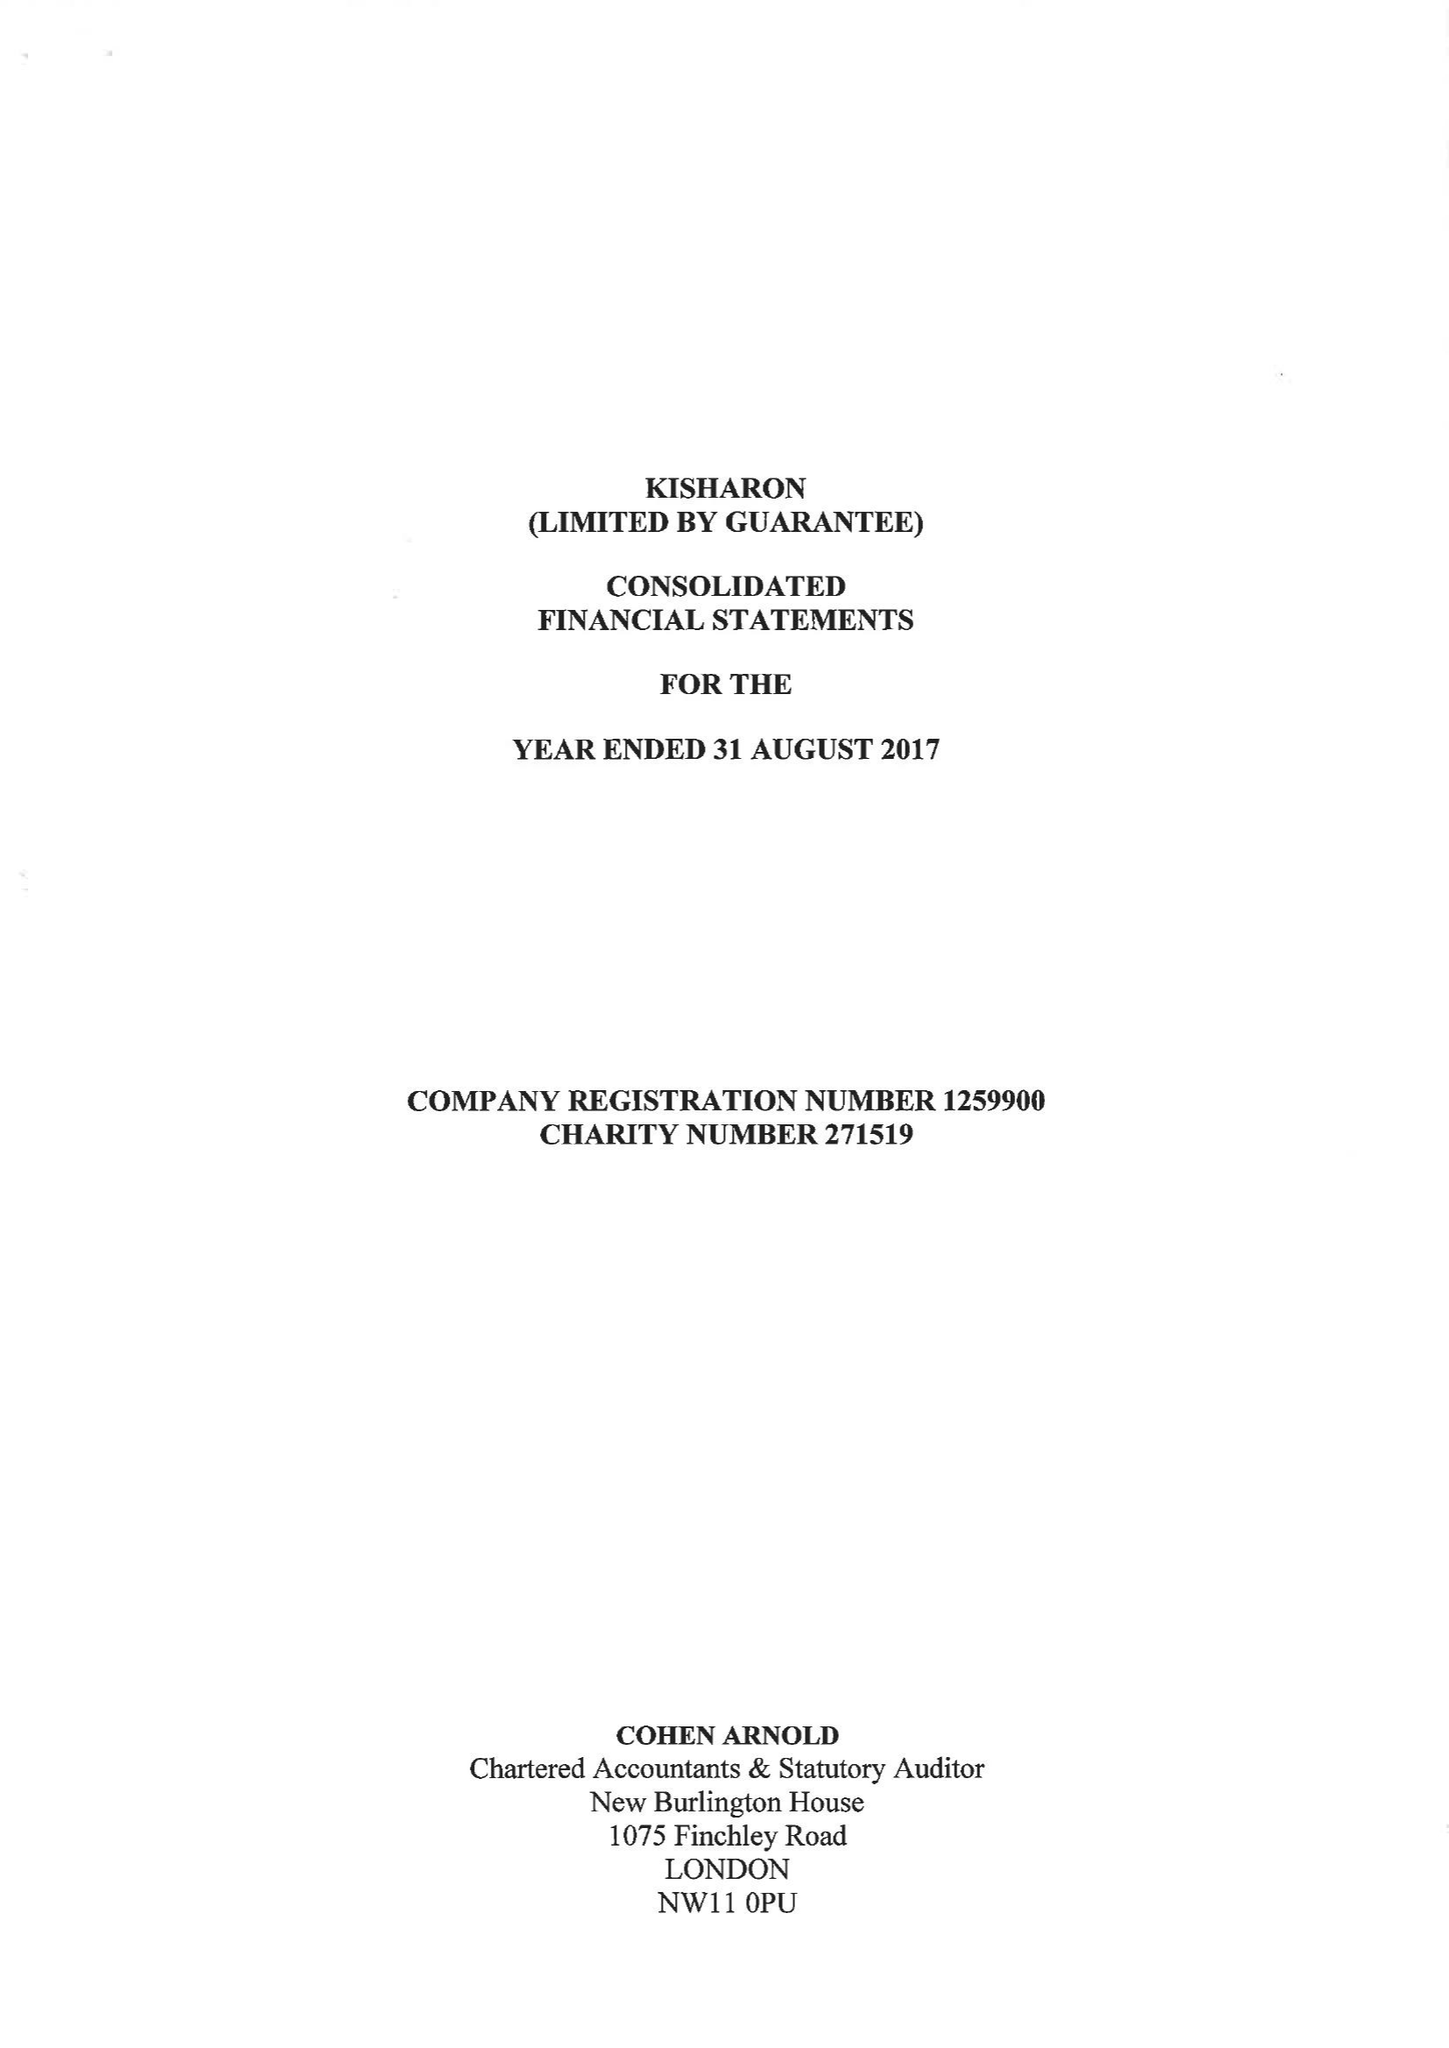What is the value for the address__postcode?
Answer the question using a single word or phrase. NW9 6TD 